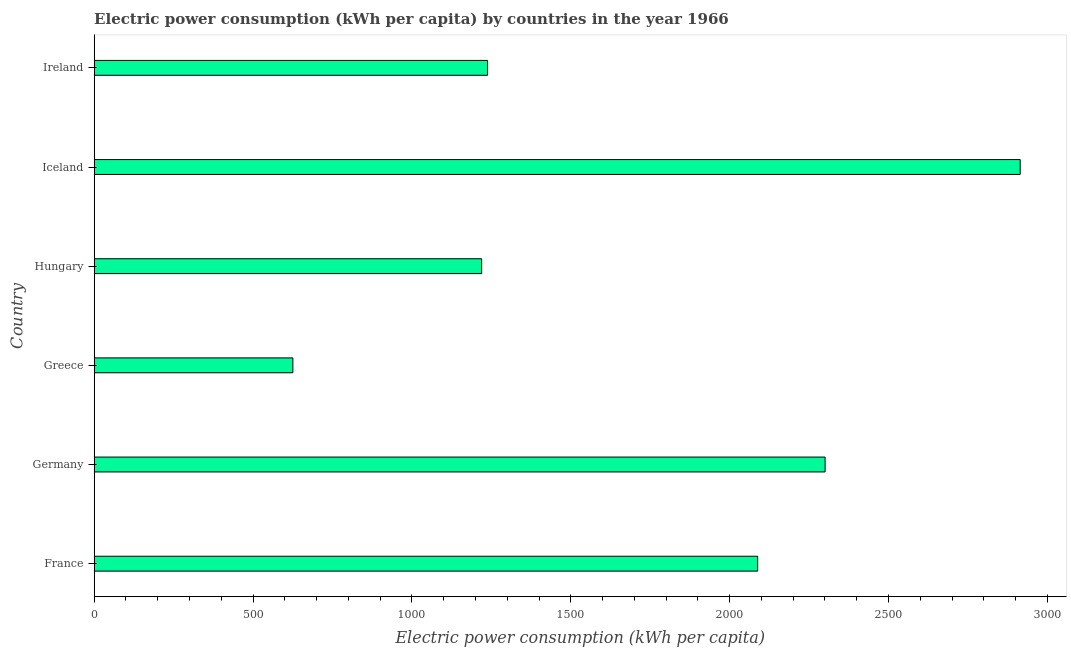Does the graph contain grids?
Provide a succinct answer. No. What is the title of the graph?
Offer a terse response. Electric power consumption (kWh per capita) by countries in the year 1966. What is the label or title of the X-axis?
Offer a very short reply. Electric power consumption (kWh per capita). What is the label or title of the Y-axis?
Keep it short and to the point. Country. What is the electric power consumption in Ireland?
Your response must be concise. 1238.23. Across all countries, what is the maximum electric power consumption?
Ensure brevity in your answer.  2914.56. Across all countries, what is the minimum electric power consumption?
Make the answer very short. 625.29. In which country was the electric power consumption maximum?
Your answer should be very brief. Iceland. What is the sum of the electric power consumption?
Ensure brevity in your answer.  1.04e+04. What is the difference between the electric power consumption in France and Greece?
Your answer should be very brief. 1463.01. What is the average electric power consumption per country?
Provide a succinct answer. 1731.06. What is the median electric power consumption?
Your response must be concise. 1663.26. What is the ratio of the electric power consumption in Greece to that in Iceland?
Keep it short and to the point. 0.21. What is the difference between the highest and the second highest electric power consumption?
Keep it short and to the point. 614.06. What is the difference between the highest and the lowest electric power consumption?
Ensure brevity in your answer.  2289.27. In how many countries, is the electric power consumption greater than the average electric power consumption taken over all countries?
Keep it short and to the point. 3. How many bars are there?
Keep it short and to the point. 6. Are the values on the major ticks of X-axis written in scientific E-notation?
Your answer should be very brief. No. What is the Electric power consumption (kWh per capita) in France?
Your answer should be very brief. 2088.29. What is the Electric power consumption (kWh per capita) in Germany?
Offer a very short reply. 2300.5. What is the Electric power consumption (kWh per capita) in Greece?
Provide a succinct answer. 625.29. What is the Electric power consumption (kWh per capita) in Hungary?
Offer a terse response. 1219.51. What is the Electric power consumption (kWh per capita) in Iceland?
Offer a terse response. 2914.56. What is the Electric power consumption (kWh per capita) in Ireland?
Provide a short and direct response. 1238.23. What is the difference between the Electric power consumption (kWh per capita) in France and Germany?
Offer a terse response. -212.21. What is the difference between the Electric power consumption (kWh per capita) in France and Greece?
Your response must be concise. 1463.01. What is the difference between the Electric power consumption (kWh per capita) in France and Hungary?
Your answer should be very brief. 868.78. What is the difference between the Electric power consumption (kWh per capita) in France and Iceland?
Give a very brief answer. -826.26. What is the difference between the Electric power consumption (kWh per capita) in France and Ireland?
Ensure brevity in your answer.  850.06. What is the difference between the Electric power consumption (kWh per capita) in Germany and Greece?
Your response must be concise. 1675.21. What is the difference between the Electric power consumption (kWh per capita) in Germany and Hungary?
Your answer should be compact. 1080.99. What is the difference between the Electric power consumption (kWh per capita) in Germany and Iceland?
Offer a terse response. -614.06. What is the difference between the Electric power consumption (kWh per capita) in Germany and Ireland?
Provide a succinct answer. 1062.27. What is the difference between the Electric power consumption (kWh per capita) in Greece and Hungary?
Provide a short and direct response. -594.23. What is the difference between the Electric power consumption (kWh per capita) in Greece and Iceland?
Your answer should be compact. -2289.27. What is the difference between the Electric power consumption (kWh per capita) in Greece and Ireland?
Make the answer very short. -612.94. What is the difference between the Electric power consumption (kWh per capita) in Hungary and Iceland?
Keep it short and to the point. -1695.04. What is the difference between the Electric power consumption (kWh per capita) in Hungary and Ireland?
Provide a short and direct response. -18.72. What is the difference between the Electric power consumption (kWh per capita) in Iceland and Ireland?
Your answer should be very brief. 1676.33. What is the ratio of the Electric power consumption (kWh per capita) in France to that in Germany?
Provide a short and direct response. 0.91. What is the ratio of the Electric power consumption (kWh per capita) in France to that in Greece?
Make the answer very short. 3.34. What is the ratio of the Electric power consumption (kWh per capita) in France to that in Hungary?
Your answer should be very brief. 1.71. What is the ratio of the Electric power consumption (kWh per capita) in France to that in Iceland?
Provide a short and direct response. 0.72. What is the ratio of the Electric power consumption (kWh per capita) in France to that in Ireland?
Your answer should be compact. 1.69. What is the ratio of the Electric power consumption (kWh per capita) in Germany to that in Greece?
Ensure brevity in your answer.  3.68. What is the ratio of the Electric power consumption (kWh per capita) in Germany to that in Hungary?
Provide a short and direct response. 1.89. What is the ratio of the Electric power consumption (kWh per capita) in Germany to that in Iceland?
Ensure brevity in your answer.  0.79. What is the ratio of the Electric power consumption (kWh per capita) in Germany to that in Ireland?
Keep it short and to the point. 1.86. What is the ratio of the Electric power consumption (kWh per capita) in Greece to that in Hungary?
Offer a very short reply. 0.51. What is the ratio of the Electric power consumption (kWh per capita) in Greece to that in Iceland?
Provide a succinct answer. 0.21. What is the ratio of the Electric power consumption (kWh per capita) in Greece to that in Ireland?
Offer a very short reply. 0.51. What is the ratio of the Electric power consumption (kWh per capita) in Hungary to that in Iceland?
Give a very brief answer. 0.42. What is the ratio of the Electric power consumption (kWh per capita) in Hungary to that in Ireland?
Provide a short and direct response. 0.98. What is the ratio of the Electric power consumption (kWh per capita) in Iceland to that in Ireland?
Provide a short and direct response. 2.35. 